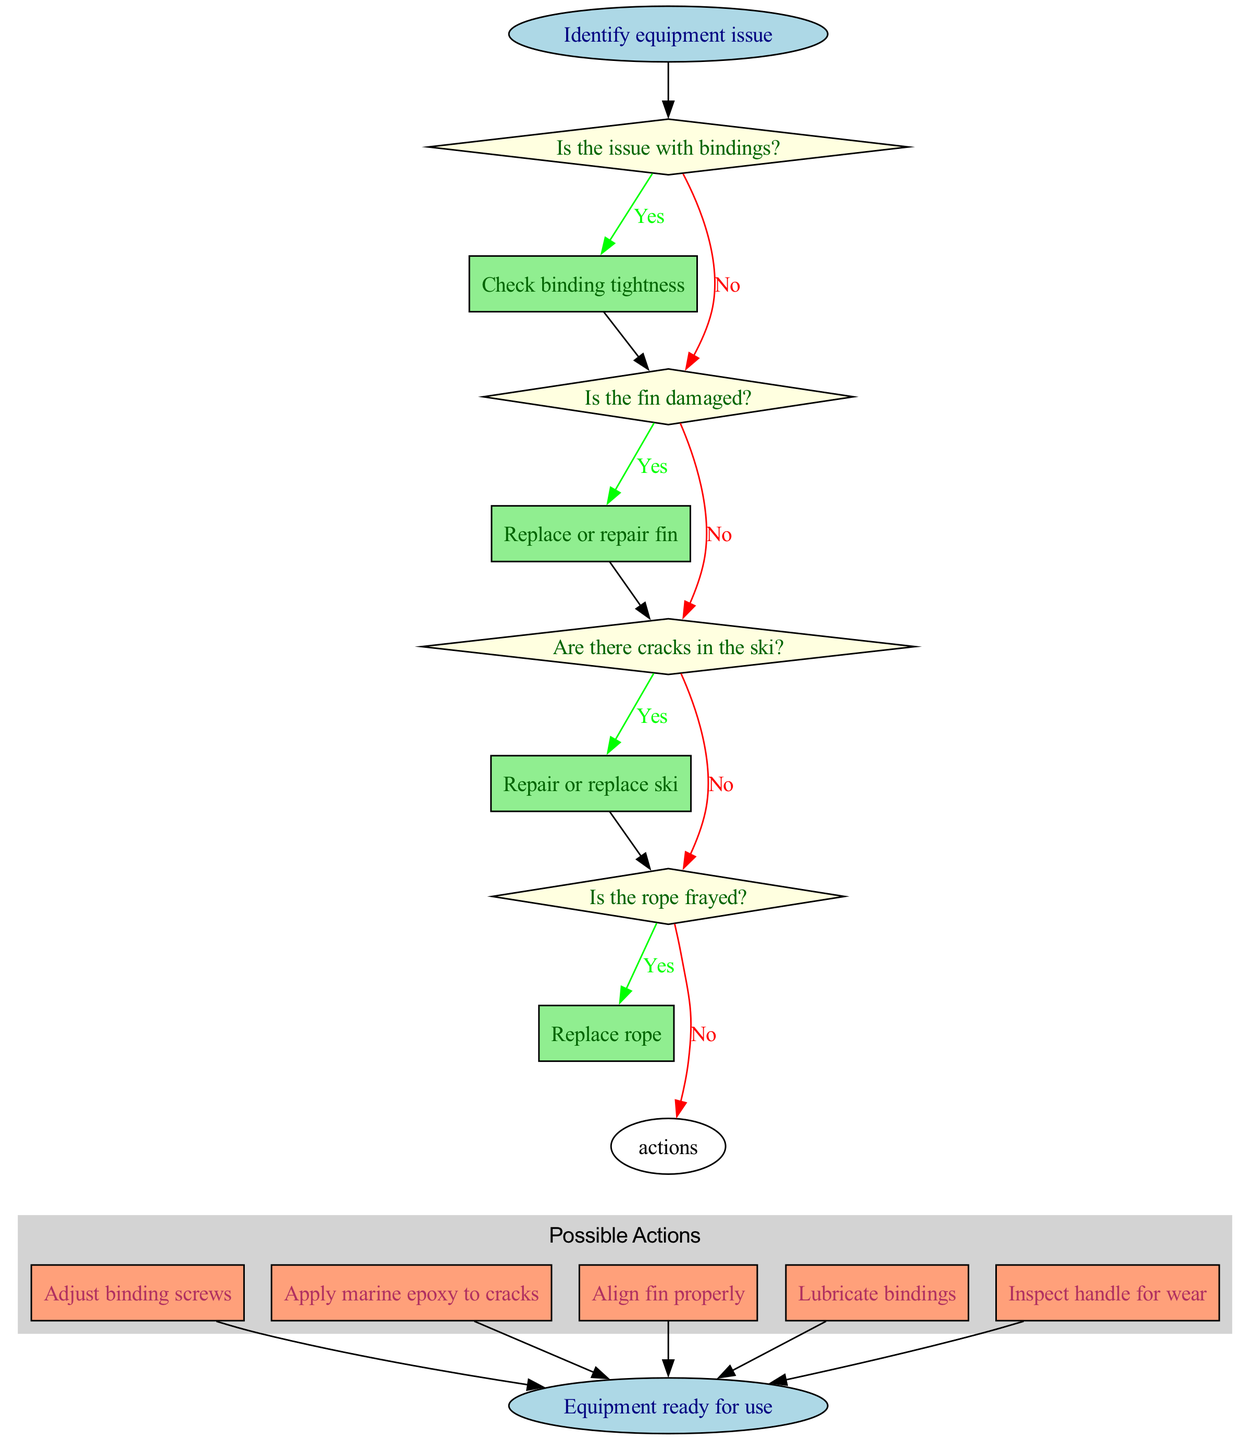What is the starting point of the troubleshooting flow chart? The starting point is labeled as "Identify equipment issue," which is the first node in the diagram.
Answer: Identify equipment issue How many decision points are in the flow chart? There are four decision nodes that ask about specific issues with the equipment, making the total count of decision points four.
Answer: 4 What action follows the question about damaged fins? The action that follows if the fin is damaged is "Replace or repair fin," which is connected to the decision question regarding fins.
Answer: Replace or repair fin What happens if the ski has cracks? If there are cracks in the ski, the flow indicates to "Repair or replace ski," which is the corresponding action for that decision node.
Answer: Repair or replace ski Which action is connected to the question about frayed rope? The action connected to the question about a frayed rope is "Replace rope," indicating the recommended next step if the rope is found to be frayed.
Answer: Replace rope What is the final result of the flow chart after all actions? The flow chart concludes with the node labeled "Equipment ready for use," indicating the end result of the troubleshooting process.
Answer: Equipment ready for use What is the color of the decision nodes in the diagram? The decision nodes are colored light yellow, as specified in the diagram attributes for those nodes.
Answer: Light yellow If the answer to "Is the issue with bindings?" is no, what is the next step? If the answer is no to that question, the flow directs to "Proceed to next check," leading to the next decision regarding the fin.
Answer: Proceed to next check What is the node style used for action items? Action items are represented in boxes with a filled style, specifically in lightsalmon color according to the diagram's design.
Answer: Box style with lightsalmon color 